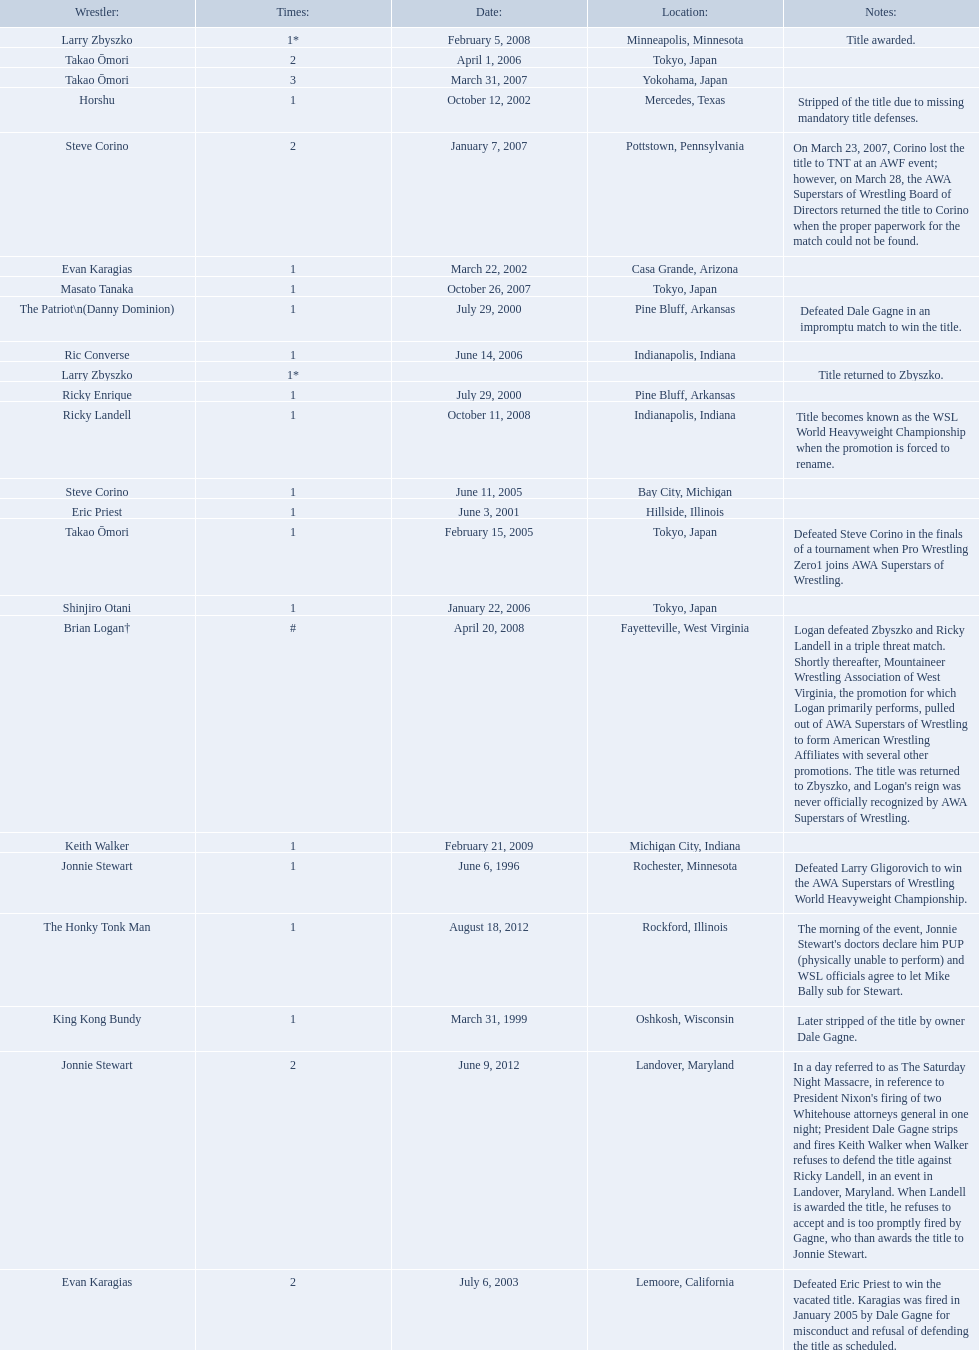Who are all of the wrestlers? Jonnie Stewart, King Kong Bundy, The Patriot\n(Danny Dominion), Ricky Enrique, Eric Priest, Evan Karagias, Horshu, Evan Karagias, Takao Ōmori, Steve Corino, Shinjiro Otani, Takao Ōmori, Ric Converse, Steve Corino, Takao Ōmori, Masato Tanaka, Larry Zbyszko, Brian Logan†, Larry Zbyszko, Ricky Landell, Keith Walker, Jonnie Stewart, The Honky Tonk Man. Where are they from? Rochester, Minnesota, Oshkosh, Wisconsin, Pine Bluff, Arkansas, Pine Bluff, Arkansas, Hillside, Illinois, Casa Grande, Arizona, Mercedes, Texas, Lemoore, California, Tokyo, Japan, Bay City, Michigan, Tokyo, Japan, Tokyo, Japan, Indianapolis, Indiana, Pottstown, Pennsylvania, Yokohama, Japan, Tokyo, Japan, Minneapolis, Minnesota, Fayetteville, West Virginia, , Indianapolis, Indiana, Michigan City, Indiana, Landover, Maryland, Rockford, Illinois. And which of them is from texas? Horshu. 